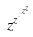<formula> <loc_0><loc_0><loc_500><loc_500>z ^ { z ^ { \cdot ^ { \cdot ^ { z ^ { z } } } } }</formula> 